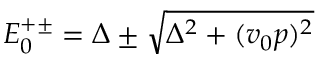Convert formula to latex. <formula><loc_0><loc_0><loc_500><loc_500>\begin{array} { r } { E _ { 0 } ^ { + \pm } = \Delta \pm \sqrt { \Delta ^ { 2 } + ( v _ { 0 } p ) ^ { 2 } } } \end{array}</formula> 